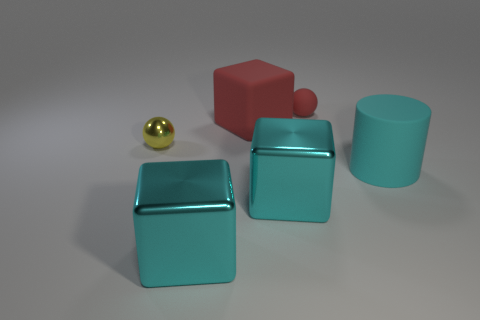Is there a red rubber object that has the same size as the red ball?
Your response must be concise. No. What is the material of the yellow object that is the same size as the red sphere?
Give a very brief answer. Metal. Does the cyan matte cylinder have the same size as the red thing that is right of the large red block?
Provide a succinct answer. No. How many rubber things are either red balls or cyan cylinders?
Ensure brevity in your answer.  2. What number of red rubber objects have the same shape as the yellow thing?
Keep it short and to the point. 1. What material is the big cube that is the same color as the small matte sphere?
Provide a short and direct response. Rubber. Is the size of the matte thing behind the red block the same as the cube that is behind the big cylinder?
Make the answer very short. No. The red rubber object to the right of the red block has what shape?
Your answer should be very brief. Sphere. What material is the other object that is the same shape as the tiny yellow metallic object?
Offer a very short reply. Rubber. There is a matte cylinder to the right of the red block; does it have the same size as the tiny yellow metallic object?
Give a very brief answer. No. 